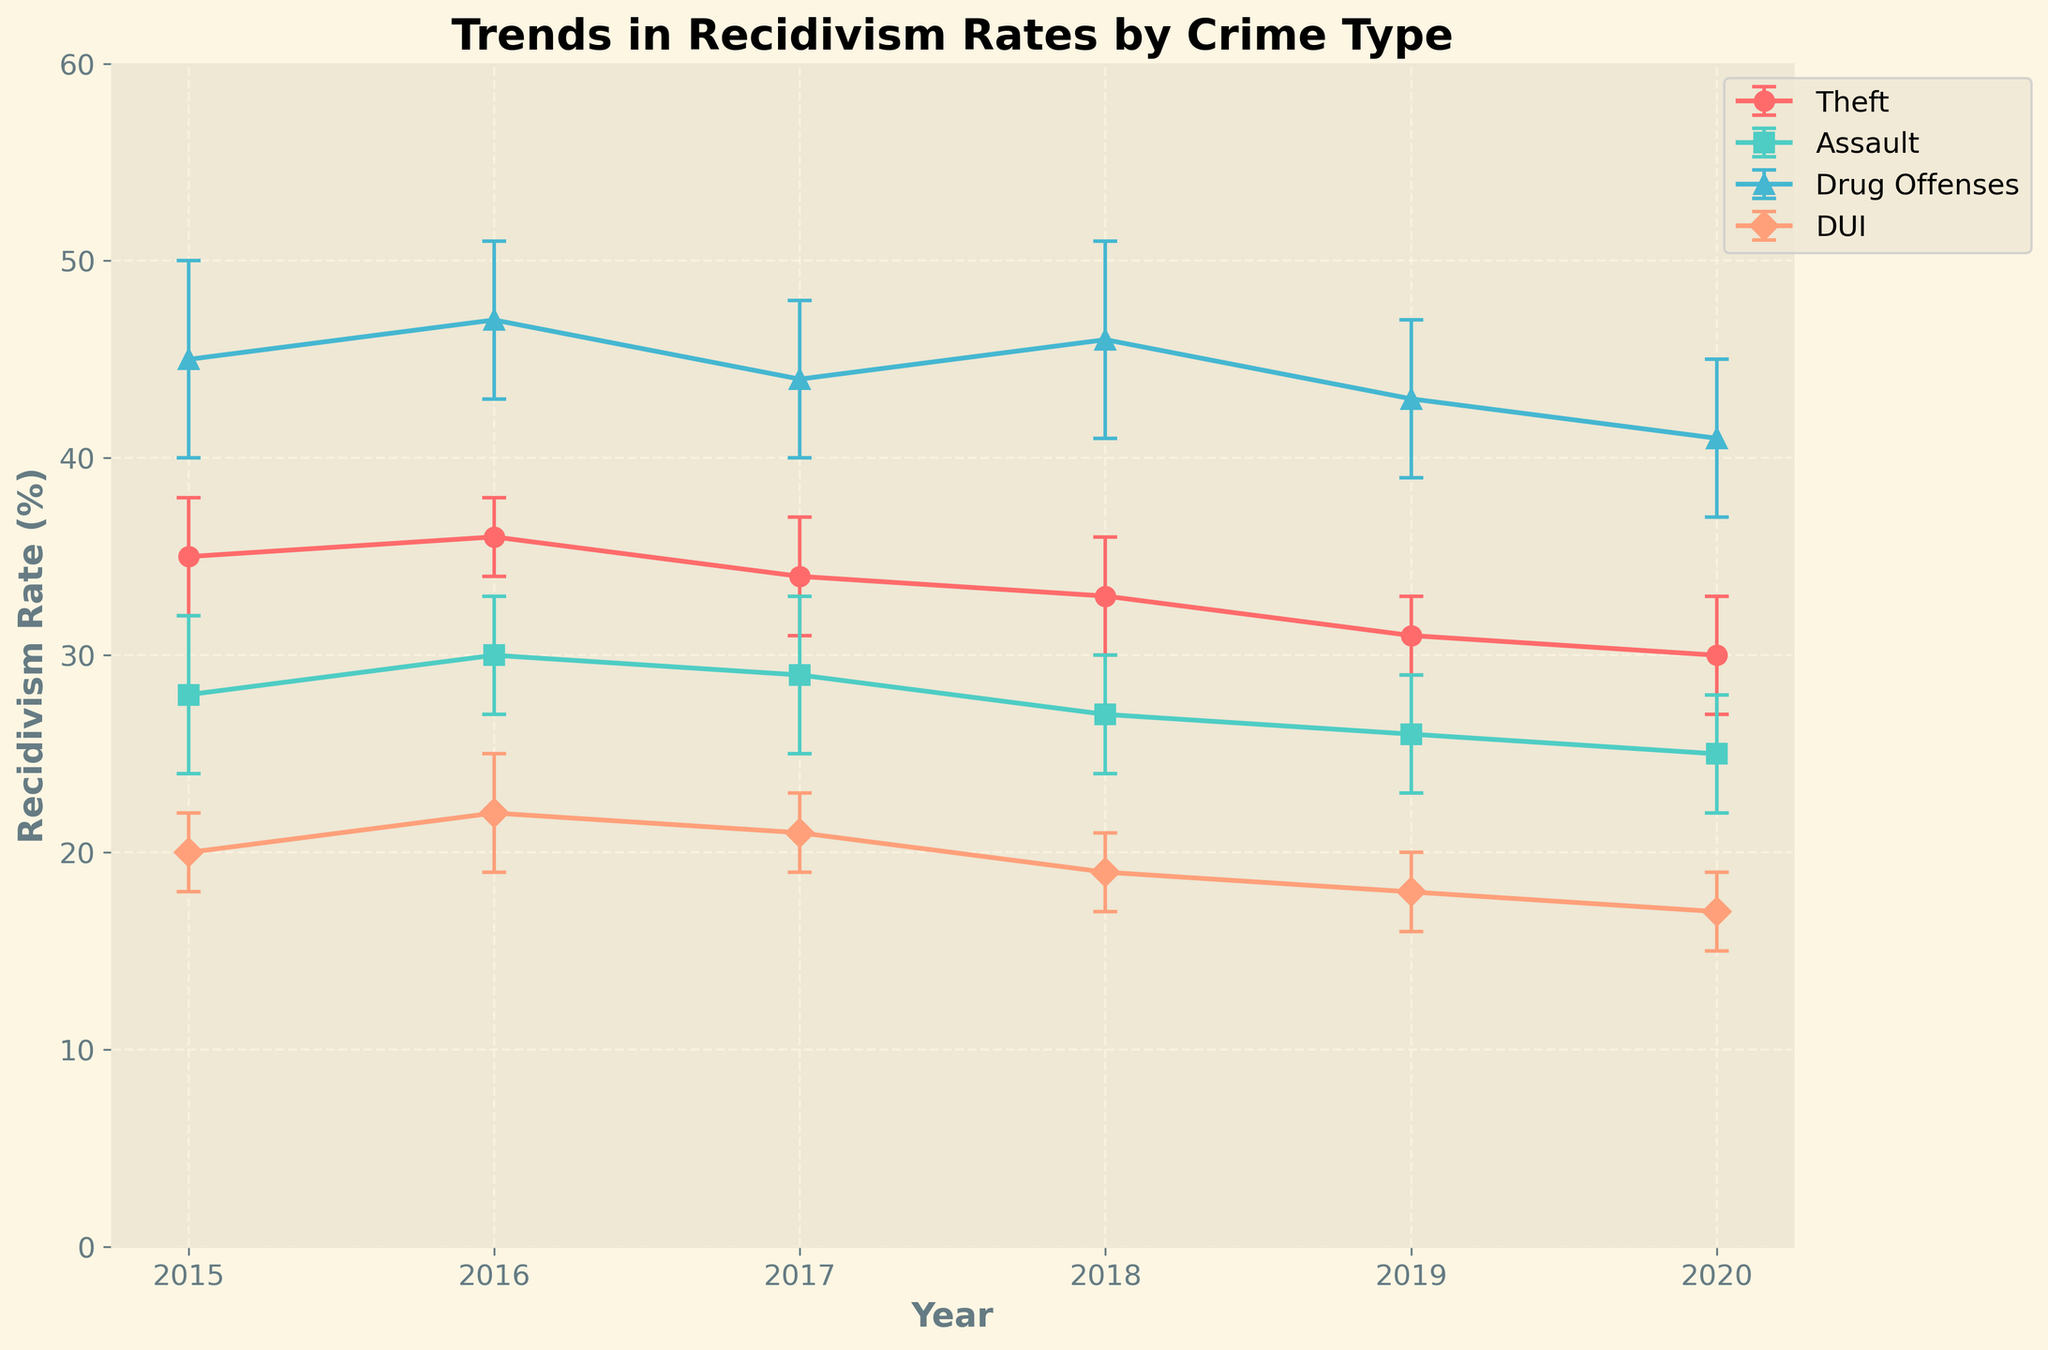What's the title of the figure? The title of the figure is typically written at the top center of the plot. In this case, the title is "Trends in Recidivism Rates by Crime Type"
Answer: Trends in Recidivism Rates by Crime Type How many crime types are depicted in the figure? By counting the distinct lines representing each type of crime along with the legend, we can see there are four types of crimes: Theft, Assault, Drug Offenses, and DUI
Answer: Four Which crime type had the highest recidivism rate in 2020? locate the year 2020 on the x-axis and compare the y-values of the points for each crime. Drug Offenses are the highest at 41%.
Answer: Drug Offenses Between which years did the recidivism rate for Assault decrease the most? Observe the line representing Assault, which is green. The biggest drop appears between 2018 and 2019, from 27% to 26%.
Answer: 2018 to 2019 What is the overall trend in recidivism rates for DUI from 2015 to 2020? Follow the line corresponding to DUI from left to right across the years. The rate decreases steadily from 20% in 2015 to 17% in 2020.
Answer: Decreasing What was the largest error bar in the entire plot, and for which year and crime type did it occur? the length of error bars in vertical directions can be compared, assess: The largest appears to belong to Drug Offenses in 2015 with a value of 5
Answer: 2015, Drug Offenses Did Theft experience a consistent trend from 2015 to 2020? Examine the line for Theft from 2015 to 2020. It shows a general decrease but with some fluctuation, particularly an increase in 2016
Answer: No Which crime type had the smallest change in recidivism rate from 2015 to 2020? Calculate the difference in recidivism rates for each crime type between 2015 and 2020. DUI shows the smallest change (from 20% to 17%)
Answer: DUI For which crime type and year was there a notable decrease following a previous increase? Look for a crime type where an increase in one year is followed by a decrease in the next. Theft increased from 2015 to 2016 and then decreased in 2017
Answer: Theft, 2017 What's the difference in recidivism rates for Drug Offenses between 2015 and 2020? By subtracting the recidivism rate in 2020 (41%) from the rate in 2015 (45%), the difference is 4%
Answer: 4% 